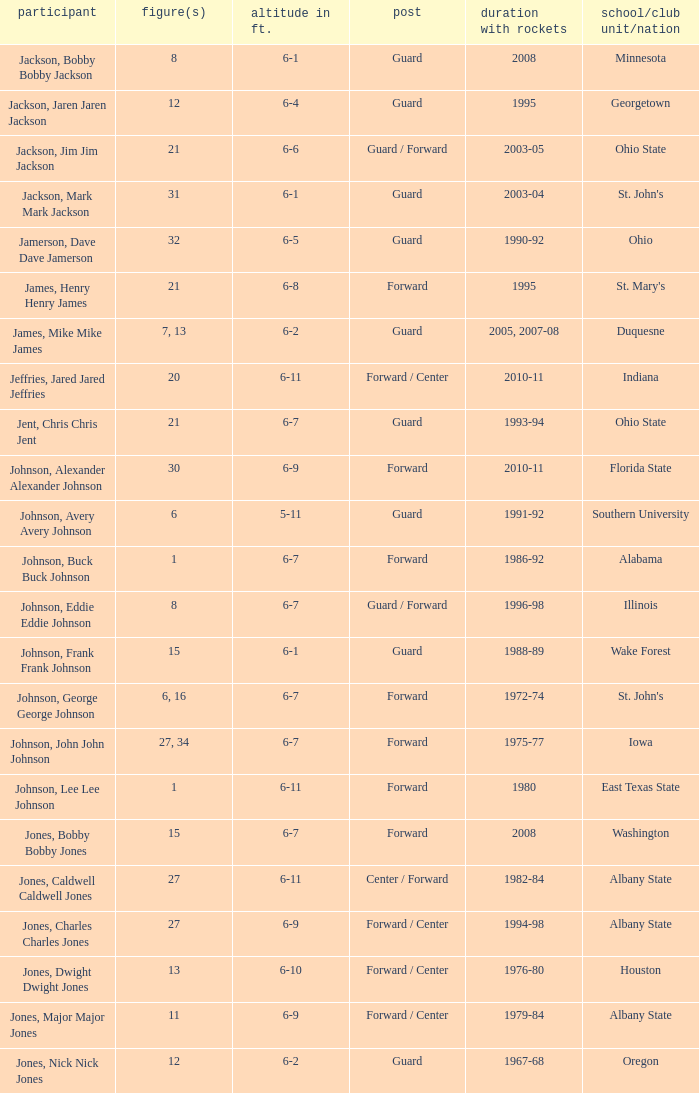Which player who played for the Rockets for the years 1986-92? Johnson, Buck Buck Johnson. 